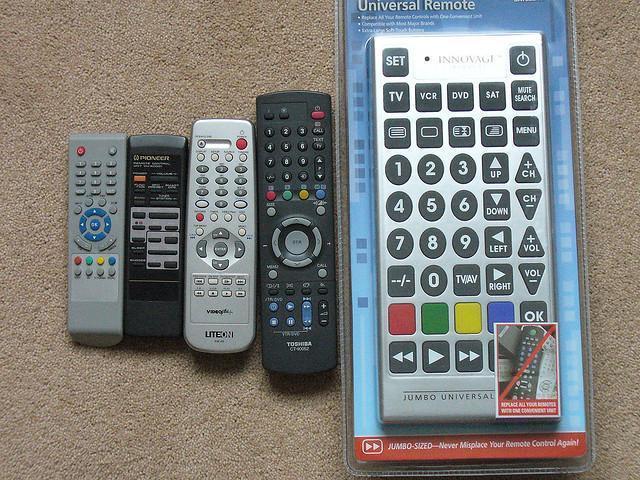How many devices are there?
Give a very brief answer. 5. How many remotes can be seen?
Give a very brief answer. 4. 